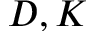<formula> <loc_0><loc_0><loc_500><loc_500>D , K</formula> 